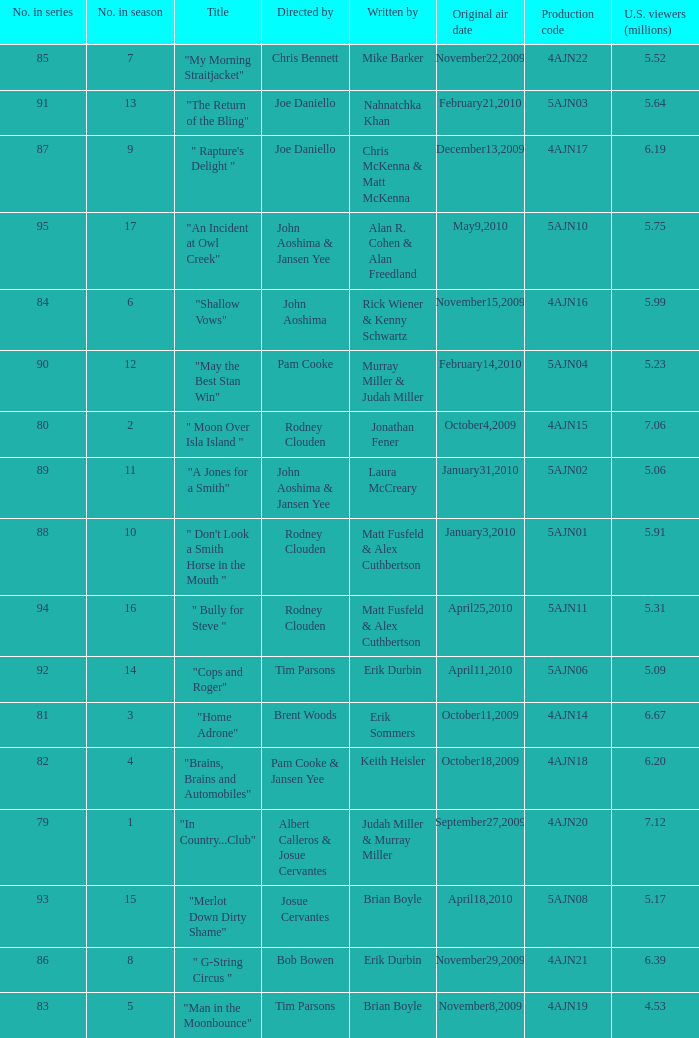Identify the writer of the episode that pam cooke and jansen yee directed. Keith Heisler. 